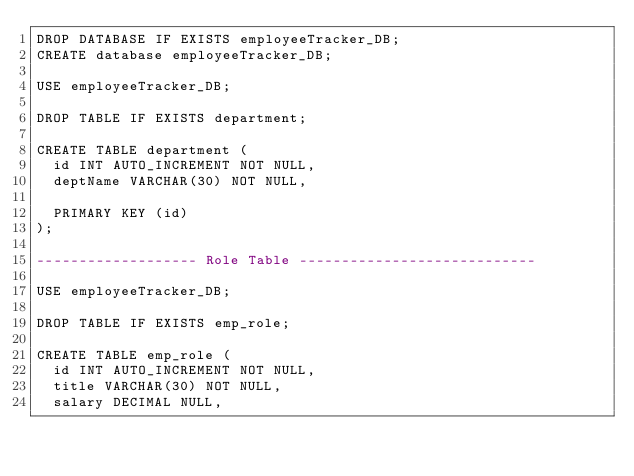<code> <loc_0><loc_0><loc_500><loc_500><_SQL_>DROP DATABASE IF EXISTS employeeTracker_DB;
CREATE database employeeTracker_DB;

USE employeeTracker_DB;

DROP TABLE IF EXISTS department;

CREATE TABLE department (
  id INT AUTO_INCREMENT NOT NULL,
  deptName VARCHAR(30) NOT NULL,

  PRIMARY KEY (id)
);

------------------- Role Table ----------------------------

USE employeeTracker_DB;

DROP TABLE IF EXISTS emp_role;

CREATE TABLE emp_role (
  id INT AUTO_INCREMENT NOT NULL,
  title VARCHAR(30) NOT NULL,
  salary DECIMAL NULL,</code> 